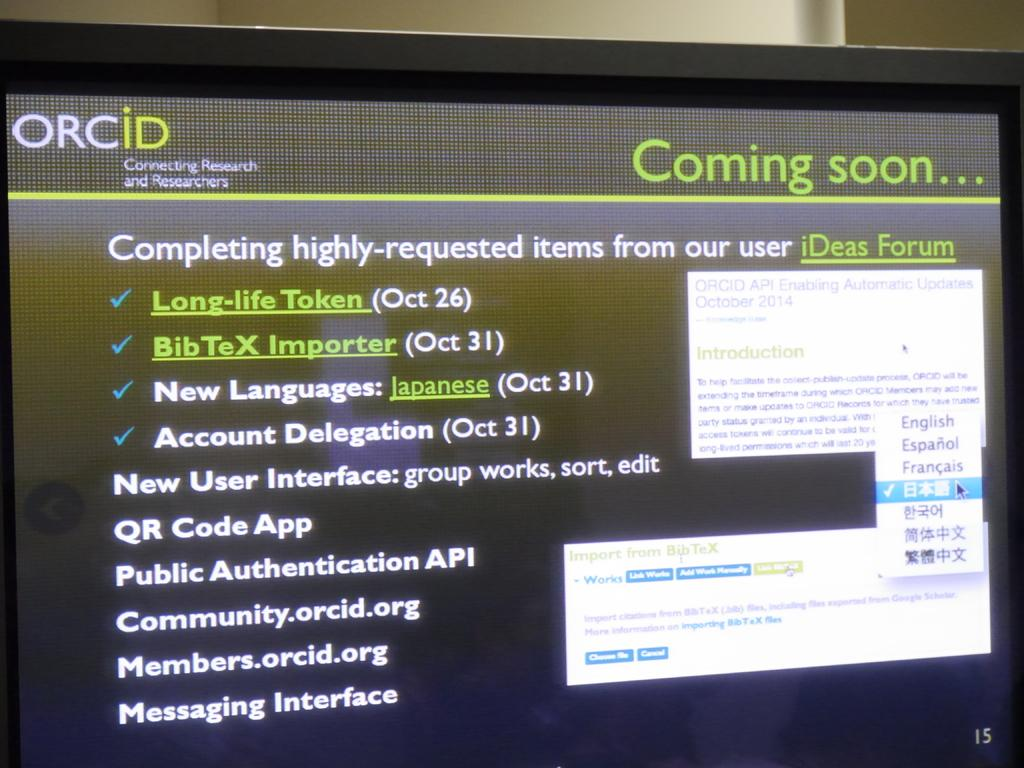<image>
Summarize the visual content of the image. Computer mointor showing a black screen and words saying Coming soon. 